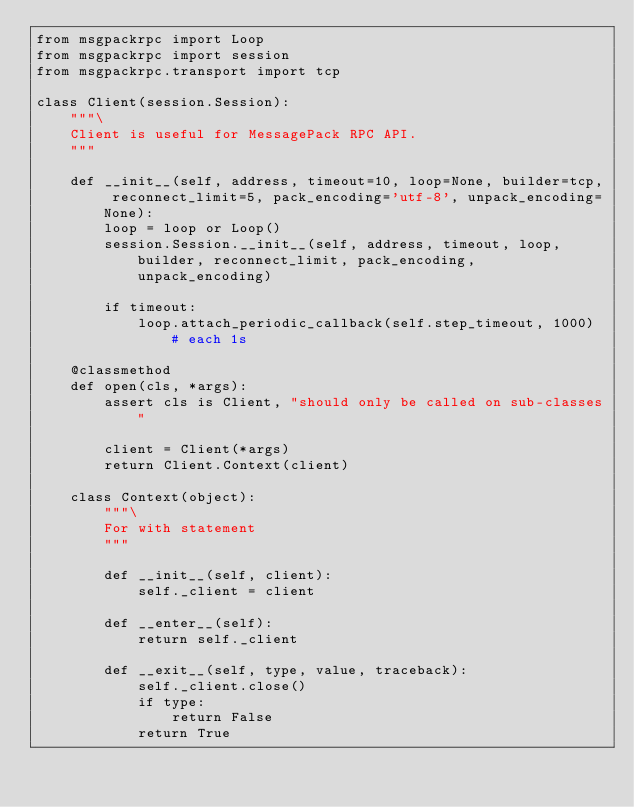Convert code to text. <code><loc_0><loc_0><loc_500><loc_500><_Python_>from msgpackrpc import Loop
from msgpackrpc import session
from msgpackrpc.transport import tcp

class Client(session.Session):
    """\
    Client is useful for MessagePack RPC API.
    """

    def __init__(self, address, timeout=10, loop=None, builder=tcp, reconnect_limit=5, pack_encoding='utf-8', unpack_encoding=None):
        loop = loop or Loop()
        session.Session.__init__(self, address, timeout, loop, builder, reconnect_limit, pack_encoding, unpack_encoding)

        if timeout:
            loop.attach_periodic_callback(self.step_timeout, 1000) # each 1s

    @classmethod
    def open(cls, *args):
        assert cls is Client, "should only be called on sub-classes"

        client = Client(*args)
        return Client.Context(client)

    class Context(object):
        """\
        For with statement
        """

        def __init__(self, client):
            self._client = client

        def __enter__(self):
            return self._client

        def __exit__(self, type, value, traceback):
            self._client.close()
            if type:
                return False
            return True
</code> 